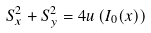<formula> <loc_0><loc_0><loc_500><loc_500>S _ { x } ^ { 2 } + S _ { y } ^ { 2 } = 4 u \left ( I _ { 0 } ( { x } ) \right )</formula> 